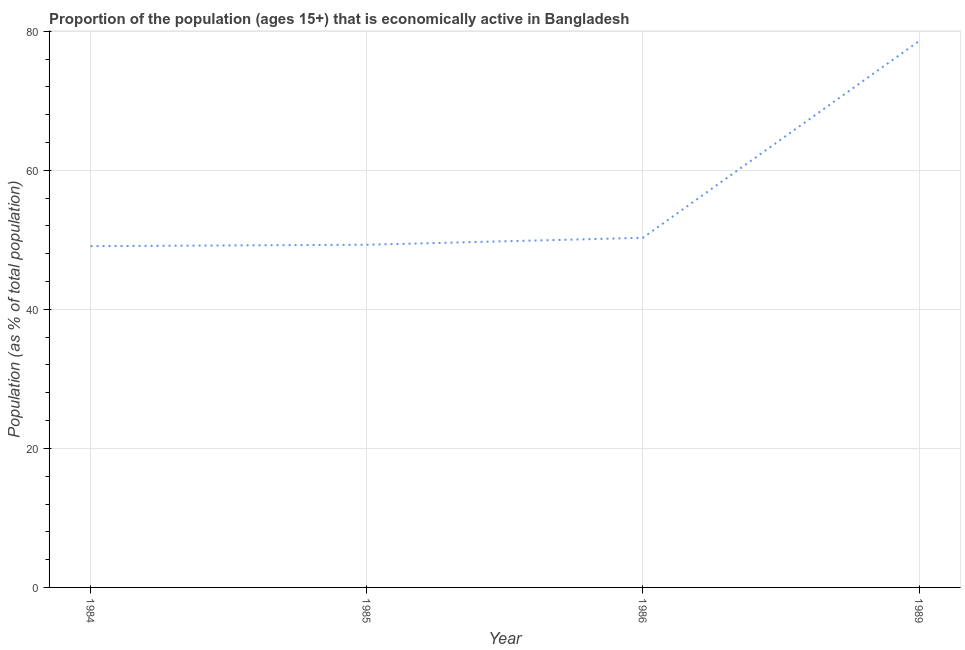What is the percentage of economically active population in 1986?
Your response must be concise. 50.3. Across all years, what is the maximum percentage of economically active population?
Offer a very short reply. 78.6. Across all years, what is the minimum percentage of economically active population?
Your answer should be very brief. 49.1. In which year was the percentage of economically active population maximum?
Keep it short and to the point. 1989. In which year was the percentage of economically active population minimum?
Make the answer very short. 1984. What is the sum of the percentage of economically active population?
Make the answer very short. 227.3. What is the difference between the percentage of economically active population in 1984 and 1986?
Keep it short and to the point. -1.2. What is the average percentage of economically active population per year?
Your answer should be compact. 56.82. What is the median percentage of economically active population?
Provide a succinct answer. 49.8. In how many years, is the percentage of economically active population greater than 12 %?
Make the answer very short. 4. What is the ratio of the percentage of economically active population in 1985 to that in 1986?
Provide a succinct answer. 0.98. Is the percentage of economically active population in 1985 less than that in 1986?
Make the answer very short. Yes. Is the difference between the percentage of economically active population in 1985 and 1986 greater than the difference between any two years?
Offer a terse response. No. What is the difference between the highest and the second highest percentage of economically active population?
Your answer should be very brief. 28.3. Is the sum of the percentage of economically active population in 1986 and 1989 greater than the maximum percentage of economically active population across all years?
Your response must be concise. Yes. What is the difference between the highest and the lowest percentage of economically active population?
Provide a succinct answer. 29.5. In how many years, is the percentage of economically active population greater than the average percentage of economically active population taken over all years?
Provide a short and direct response. 1. Does the percentage of economically active population monotonically increase over the years?
Your response must be concise. Yes. How many lines are there?
Offer a very short reply. 1. How many years are there in the graph?
Keep it short and to the point. 4. Are the values on the major ticks of Y-axis written in scientific E-notation?
Give a very brief answer. No. Does the graph contain any zero values?
Your answer should be compact. No. Does the graph contain grids?
Give a very brief answer. Yes. What is the title of the graph?
Offer a very short reply. Proportion of the population (ages 15+) that is economically active in Bangladesh. What is the label or title of the Y-axis?
Offer a very short reply. Population (as % of total population). What is the Population (as % of total population) of 1984?
Provide a succinct answer. 49.1. What is the Population (as % of total population) of 1985?
Provide a short and direct response. 49.3. What is the Population (as % of total population) in 1986?
Your answer should be compact. 50.3. What is the Population (as % of total population) of 1989?
Give a very brief answer. 78.6. What is the difference between the Population (as % of total population) in 1984 and 1985?
Your response must be concise. -0.2. What is the difference between the Population (as % of total population) in 1984 and 1986?
Offer a terse response. -1.2. What is the difference between the Population (as % of total population) in 1984 and 1989?
Provide a short and direct response. -29.5. What is the difference between the Population (as % of total population) in 1985 and 1989?
Provide a short and direct response. -29.3. What is the difference between the Population (as % of total population) in 1986 and 1989?
Your answer should be very brief. -28.3. What is the ratio of the Population (as % of total population) in 1984 to that in 1985?
Provide a short and direct response. 1. What is the ratio of the Population (as % of total population) in 1984 to that in 1986?
Offer a terse response. 0.98. What is the ratio of the Population (as % of total population) in 1984 to that in 1989?
Keep it short and to the point. 0.62. What is the ratio of the Population (as % of total population) in 1985 to that in 1989?
Offer a very short reply. 0.63. What is the ratio of the Population (as % of total population) in 1986 to that in 1989?
Keep it short and to the point. 0.64. 